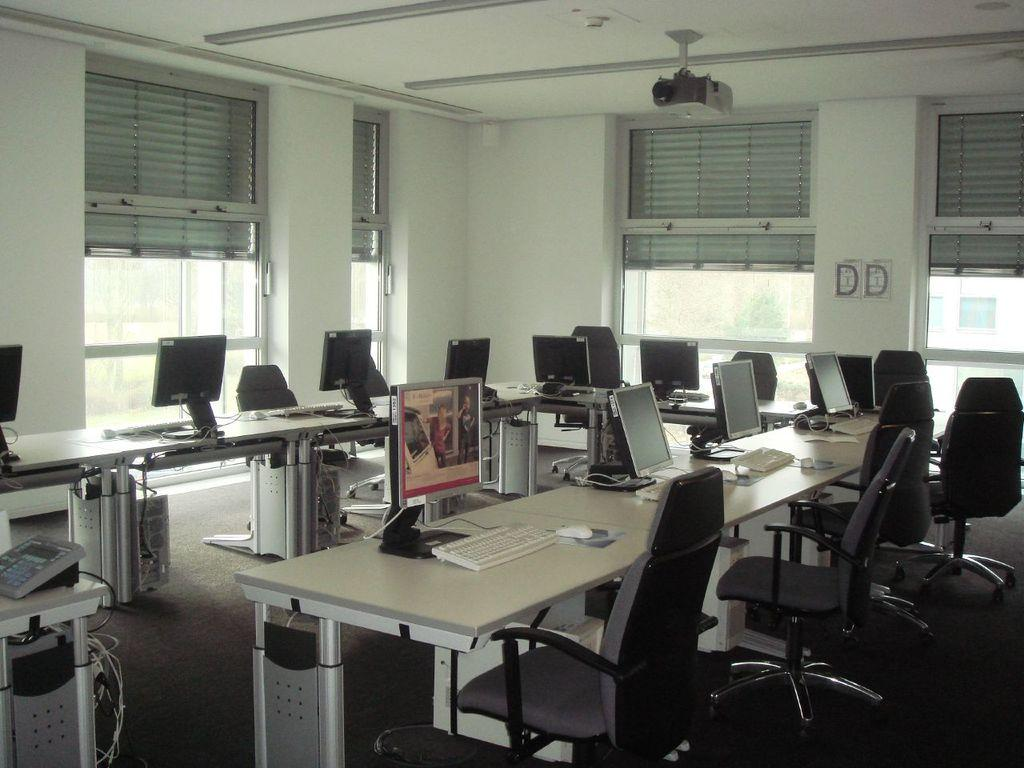What type of electronic devices are visible in the image? There are monitors, keyboards, and mouses in the image. Where are these devices located? The monitors, keyboards, and mouses are on tables in the image. What other communication device can be seen in the image? There is a telephone in the image. What type of furniture is on the floor in the image? There are chairs on the floor in the image. What can be seen in the background of the image? There are windows visible in the background of the image. Is there a writer sitting at a desk near the coast in the image? There is no writer or coast present in the image; it features electronic devices and furniture in an indoor setting. 